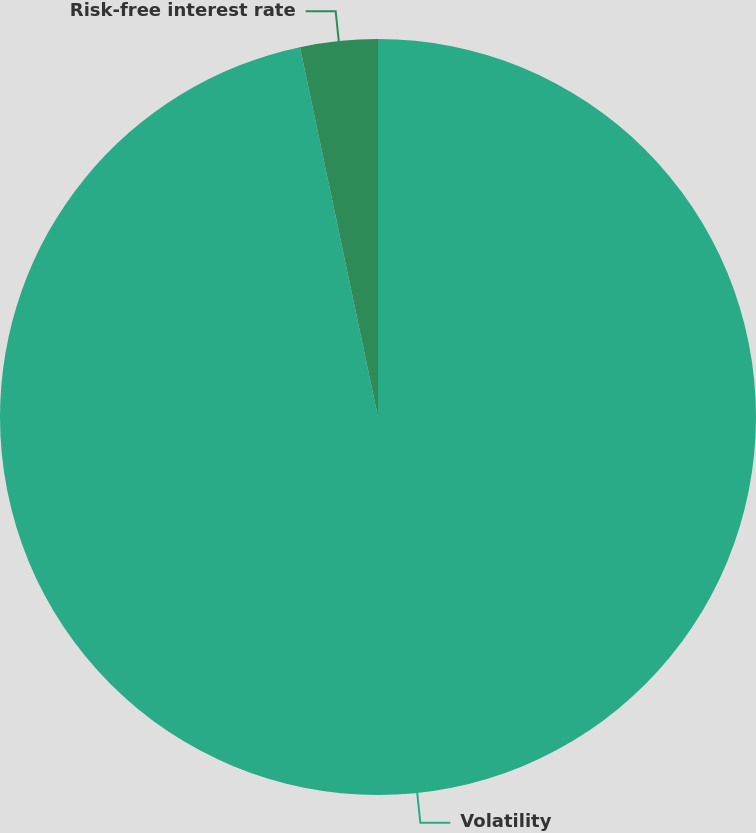Convert chart to OTSL. <chart><loc_0><loc_0><loc_500><loc_500><pie_chart><fcel>Volatility<fcel>Risk-free interest rate<nl><fcel>96.69%<fcel>3.31%<nl></chart> 